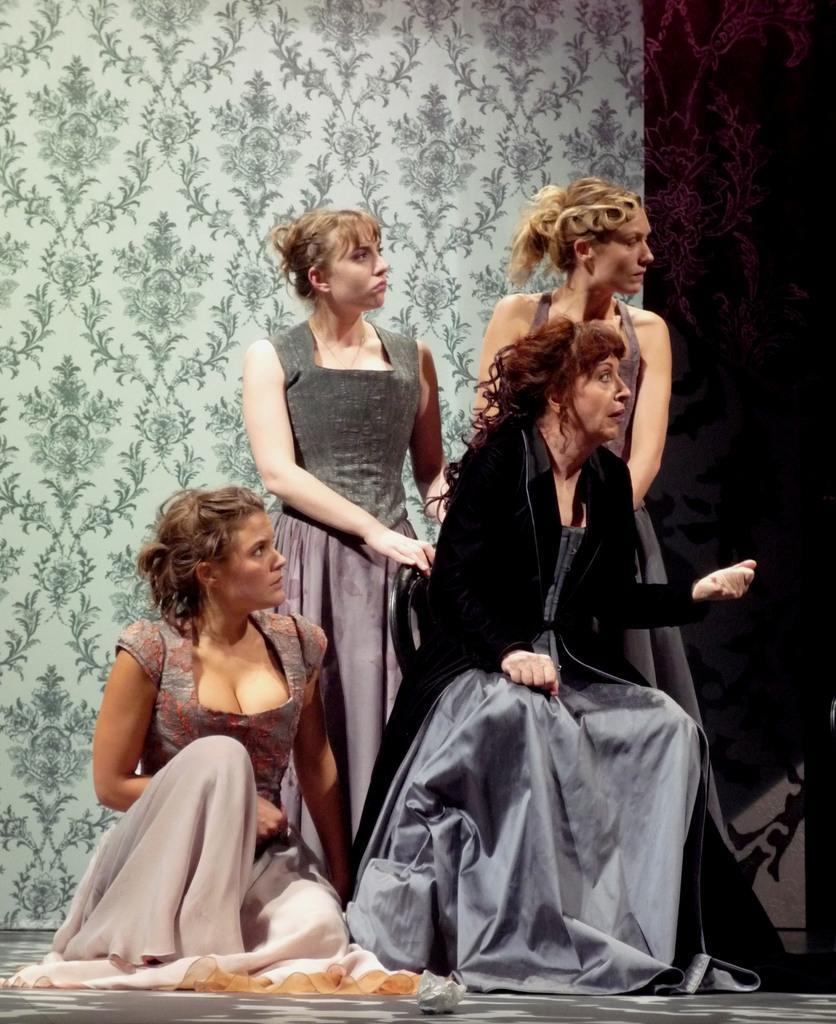How would you summarize this image in a sentence or two? In this picture I can observe four women. Two of them are sitting and the remaining two are standing. All of them are looking on the right side. In the background there is a wall. 